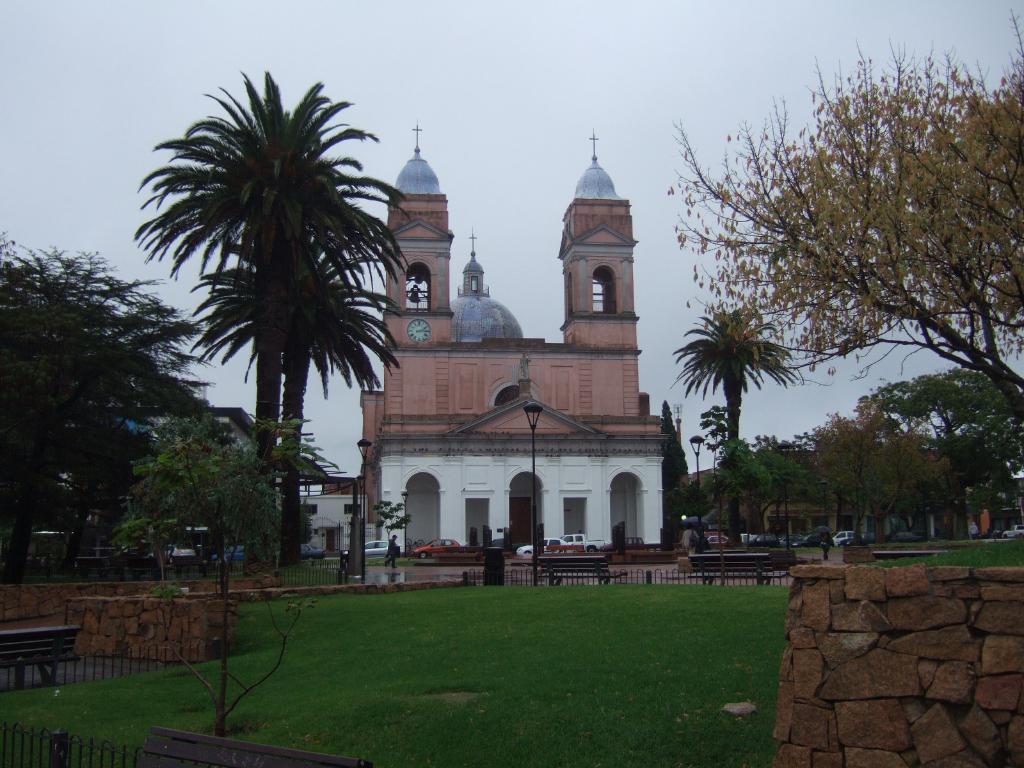Describe this image in one or two sentences. In this picture we can see the grass, fences, benches, walls, vehicles, trees, buildings, light poles and some people and some objects and in the background we can see the sky. 